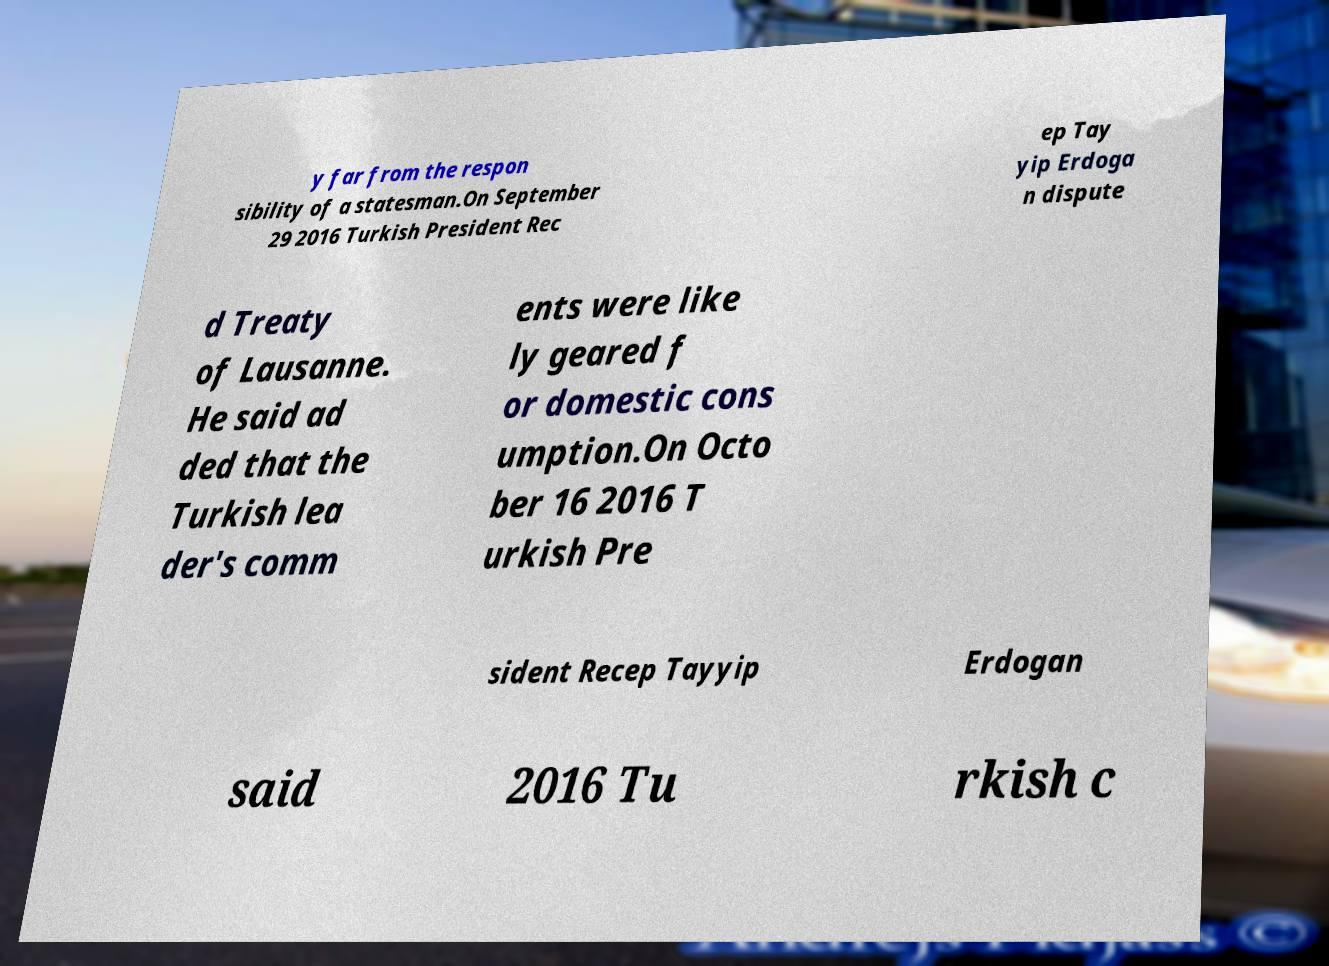Can you accurately transcribe the text from the provided image for me? y far from the respon sibility of a statesman.On September 29 2016 Turkish President Rec ep Tay yip Erdoga n dispute d Treaty of Lausanne. He said ad ded that the Turkish lea der's comm ents were like ly geared f or domestic cons umption.On Octo ber 16 2016 T urkish Pre sident Recep Tayyip Erdogan said 2016 Tu rkish c 